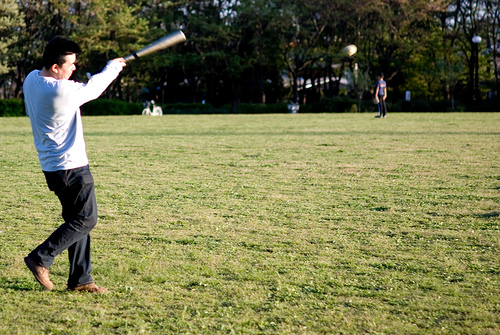<image>What type of mitt do you see? There is no mitt in the image. However, it could potentially be a baseball mitt. What type of mitt do you see? I don't know what type of mitt is in the image. It is possible that there is no mitt in sight. 